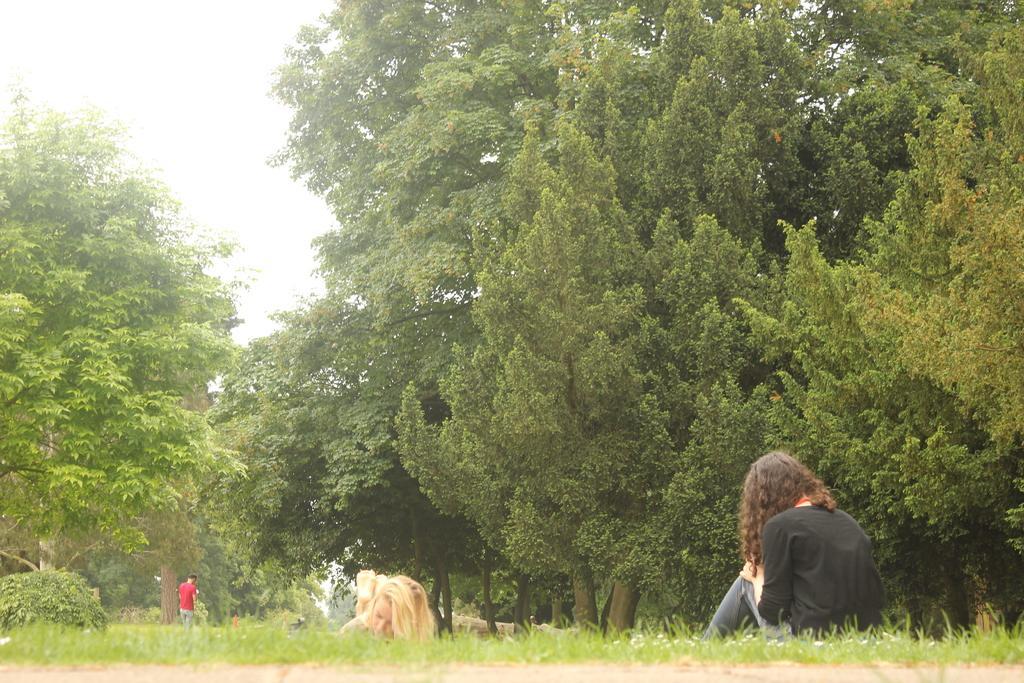In one or two sentences, can you explain what this image depicts? In this image I see 2 women who are on the grass and I see a person over here who is wearing red t-shirt and blue jeans and I see trees. In the background I see the clear sky. 